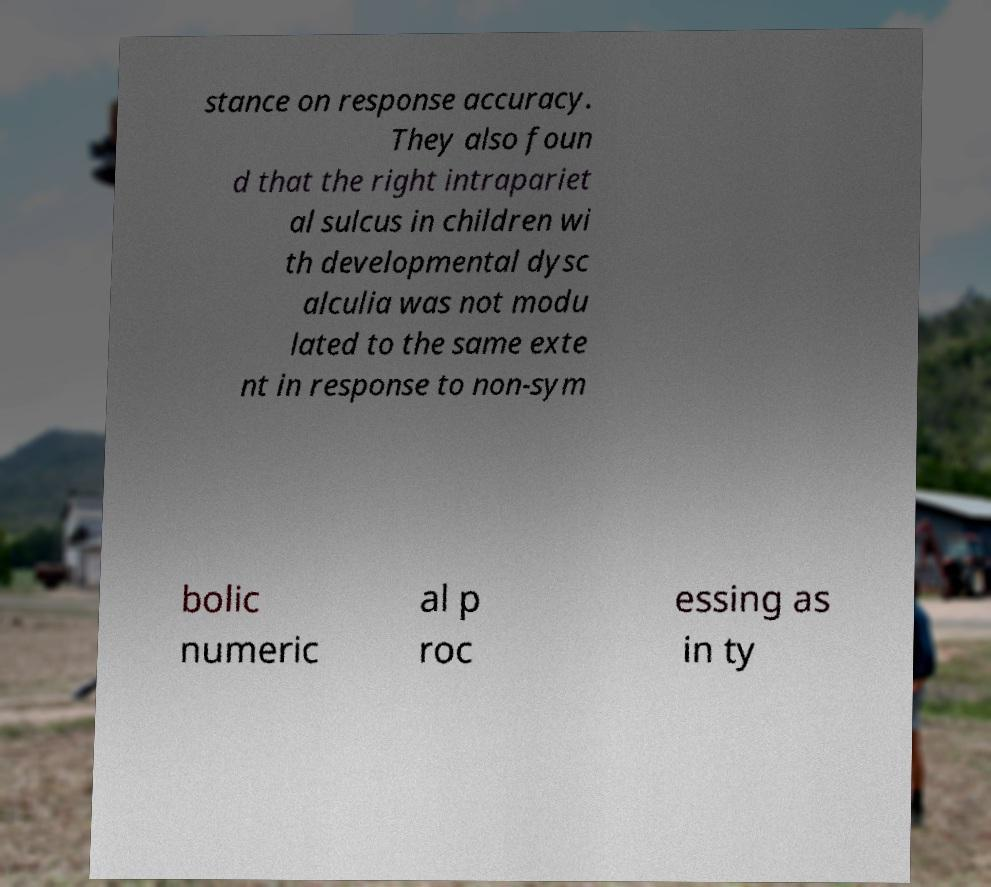There's text embedded in this image that I need extracted. Can you transcribe it verbatim? stance on response accuracy. They also foun d that the right intrapariet al sulcus in children wi th developmental dysc alculia was not modu lated to the same exte nt in response to non-sym bolic numeric al p roc essing as in ty 